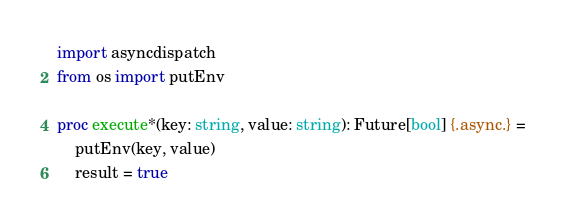<code> <loc_0><loc_0><loc_500><loc_500><_Nim_>import asyncdispatch
from os import putEnv

proc execute*(key: string, value: string): Future[bool] {.async.} = 
    putEnv(key, value)
    result = true</code> 